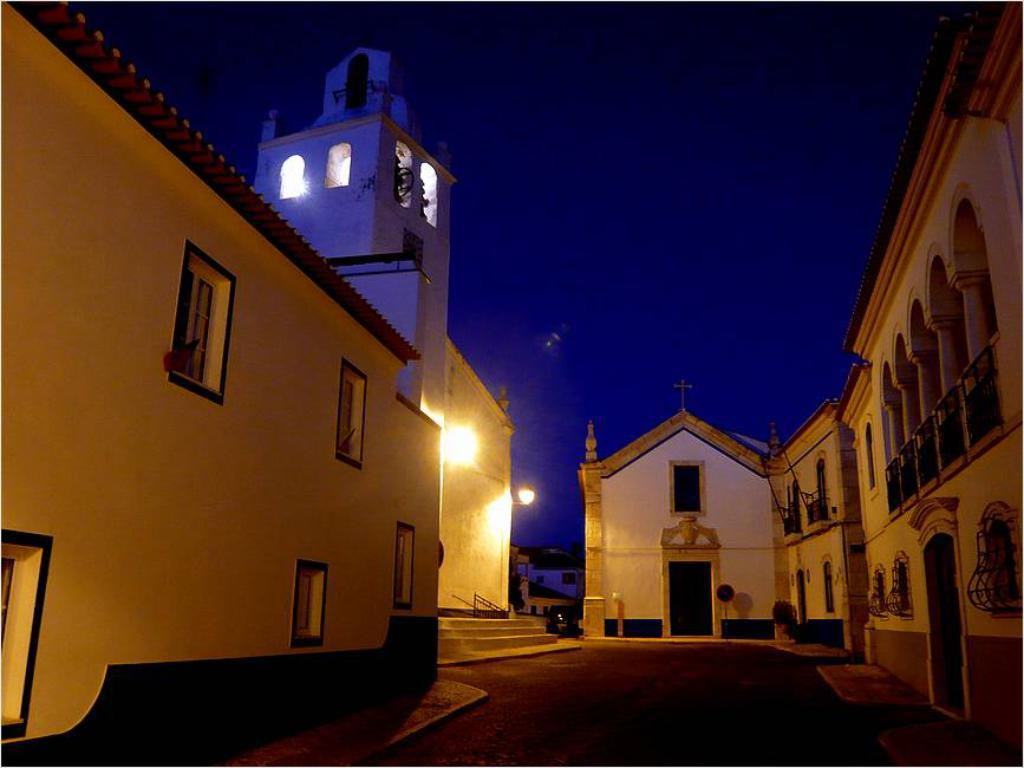What type of structures can be seen in the image? There are buildings in the image. What else can be seen in the image besides the buildings? There are lights visible in the image. What can be seen in the background of the image? The sky is visible in the background of the image. What type of hat is the building wearing in the image? Buildings do not wear hats, so this question cannot be answered. 